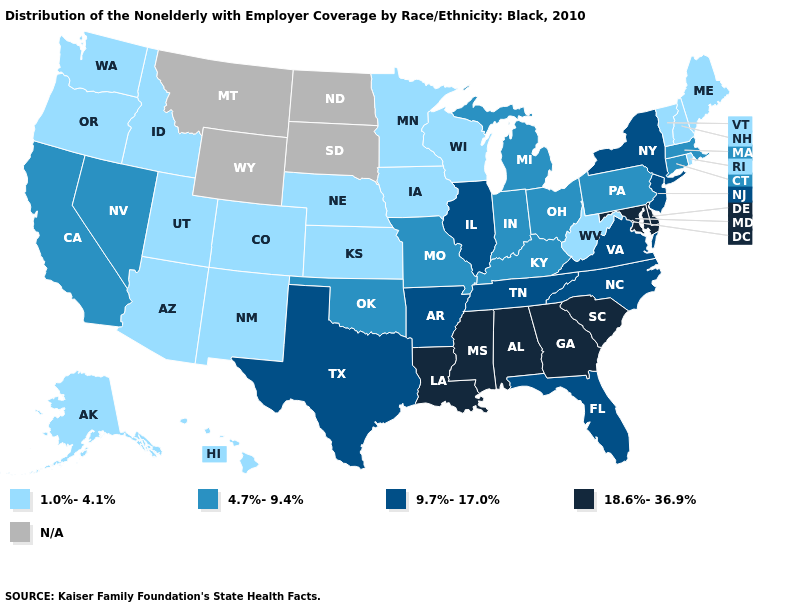Does the map have missing data?
Answer briefly. Yes. Which states have the lowest value in the USA?
Give a very brief answer. Alaska, Arizona, Colorado, Hawaii, Idaho, Iowa, Kansas, Maine, Minnesota, Nebraska, New Hampshire, New Mexico, Oregon, Rhode Island, Utah, Vermont, Washington, West Virginia, Wisconsin. What is the value of New York?
Short answer required. 9.7%-17.0%. What is the highest value in states that border New Mexico?
Short answer required. 9.7%-17.0%. What is the value of Michigan?
Answer briefly. 4.7%-9.4%. Does the map have missing data?
Answer briefly. Yes. What is the value of Minnesota?
Answer briefly. 1.0%-4.1%. Name the states that have a value in the range 4.7%-9.4%?
Answer briefly. California, Connecticut, Indiana, Kentucky, Massachusetts, Michigan, Missouri, Nevada, Ohio, Oklahoma, Pennsylvania. Does Delaware have the highest value in the USA?
Give a very brief answer. Yes. Which states have the lowest value in the USA?
Keep it brief. Alaska, Arizona, Colorado, Hawaii, Idaho, Iowa, Kansas, Maine, Minnesota, Nebraska, New Hampshire, New Mexico, Oregon, Rhode Island, Utah, Vermont, Washington, West Virginia, Wisconsin. What is the value of Colorado?
Quick response, please. 1.0%-4.1%. Name the states that have a value in the range 1.0%-4.1%?
Answer briefly. Alaska, Arizona, Colorado, Hawaii, Idaho, Iowa, Kansas, Maine, Minnesota, Nebraska, New Hampshire, New Mexico, Oregon, Rhode Island, Utah, Vermont, Washington, West Virginia, Wisconsin. What is the value of California?
Give a very brief answer. 4.7%-9.4%. Name the states that have a value in the range 1.0%-4.1%?
Give a very brief answer. Alaska, Arizona, Colorado, Hawaii, Idaho, Iowa, Kansas, Maine, Minnesota, Nebraska, New Hampshire, New Mexico, Oregon, Rhode Island, Utah, Vermont, Washington, West Virginia, Wisconsin. 